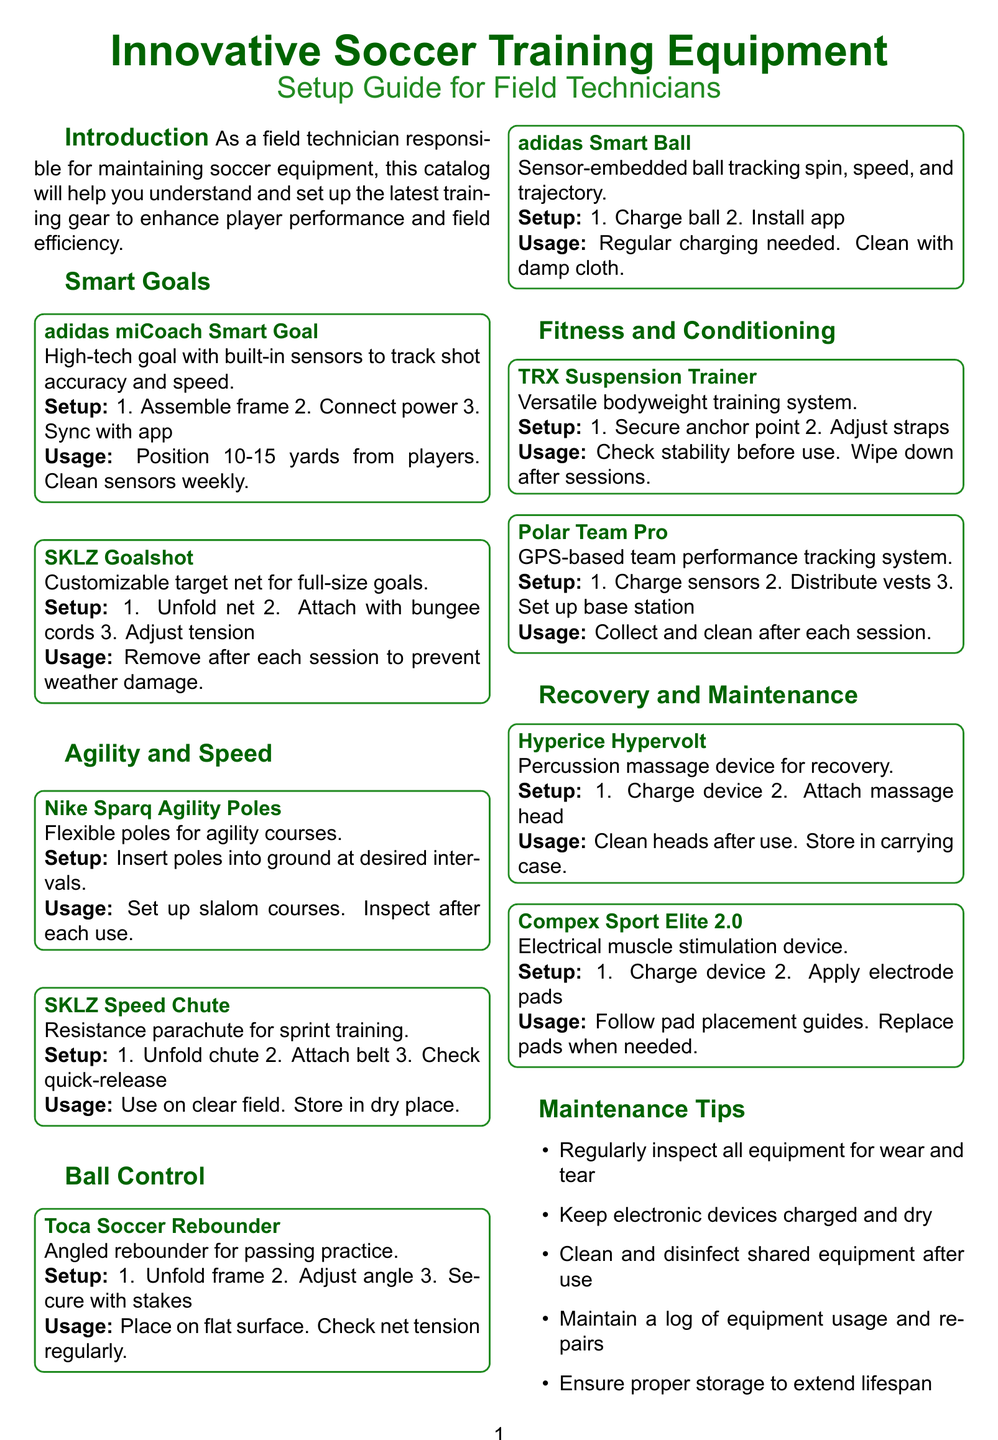What is the title of the brochure? The title of the brochure appears prominently at the top of the document, identifying its theme.
Answer: Innovative Soccer Training Equipment: Setup Guide for Field Technicians Who is the contact person for the equipment? The document provides the name of the individual responsible for field maintenance in the contact information section.
Answer: John Smith What product is used for sprint training? This product is specifically mentioned under the Fitness and Conditioning section for sprint training purposes.
Answer: SKLZ Speed Chute How many items are listed in the Smart Goals category? By counting the items in the Smart Goals section, you can find the total number.
Answer: 2 What is the primary usage for the adidas miCoach Smart Goal? The document specifies the intended use or application of this product under its usage guidelines.
Answer: Shooting practice What is one of the maintenance tips provided in the brochure? The maintenance section lists actions that should be taken to keep the equipment in good condition.
Answer: Clean and disinfect shared equipment after each use What should you do to the Nike Sparq Agility Poles after each use? The document recommends some specific actions after using this equipment to ensure its longevity.
Answer: Inspect for damage after each use What color is associated with the document's main theme? The color scheme used throughout the brochure often reflects the main theme and branding.
Answer: Green 